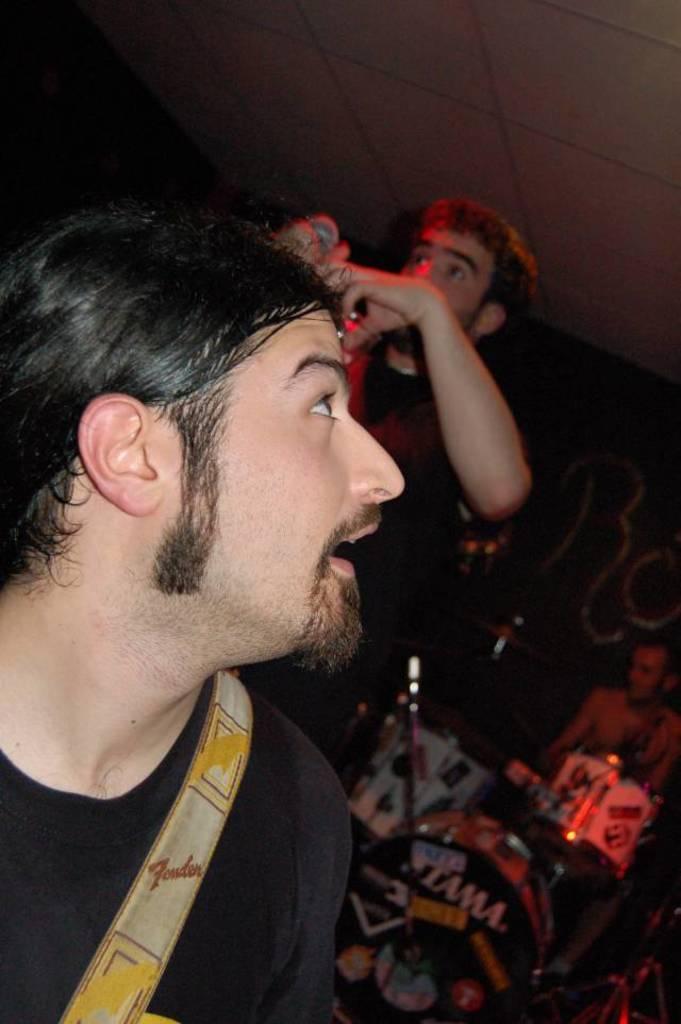Could you give a brief overview of what you see in this image? In this image there is a person truncated towards the bottom of the image, there is a person standing and holding an object, there is a person playing musical instruments, there is roof truncated truncated towards the top of the image, there is the wall truncated towards the right of the image, there is text on the wall, there is wall truncated towards the left of the image. 